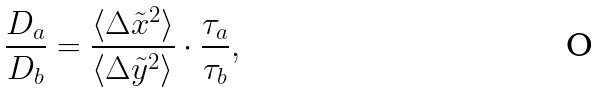<formula> <loc_0><loc_0><loc_500><loc_500>\frac { D _ { a } } { D _ { b } } = \frac { \langle \Delta \tilde { x } ^ { 2 } \rangle } { \langle \Delta \tilde { y } ^ { 2 } \rangle } \cdot \frac { \tau _ { a } } { \tau _ { b } } ,</formula> 